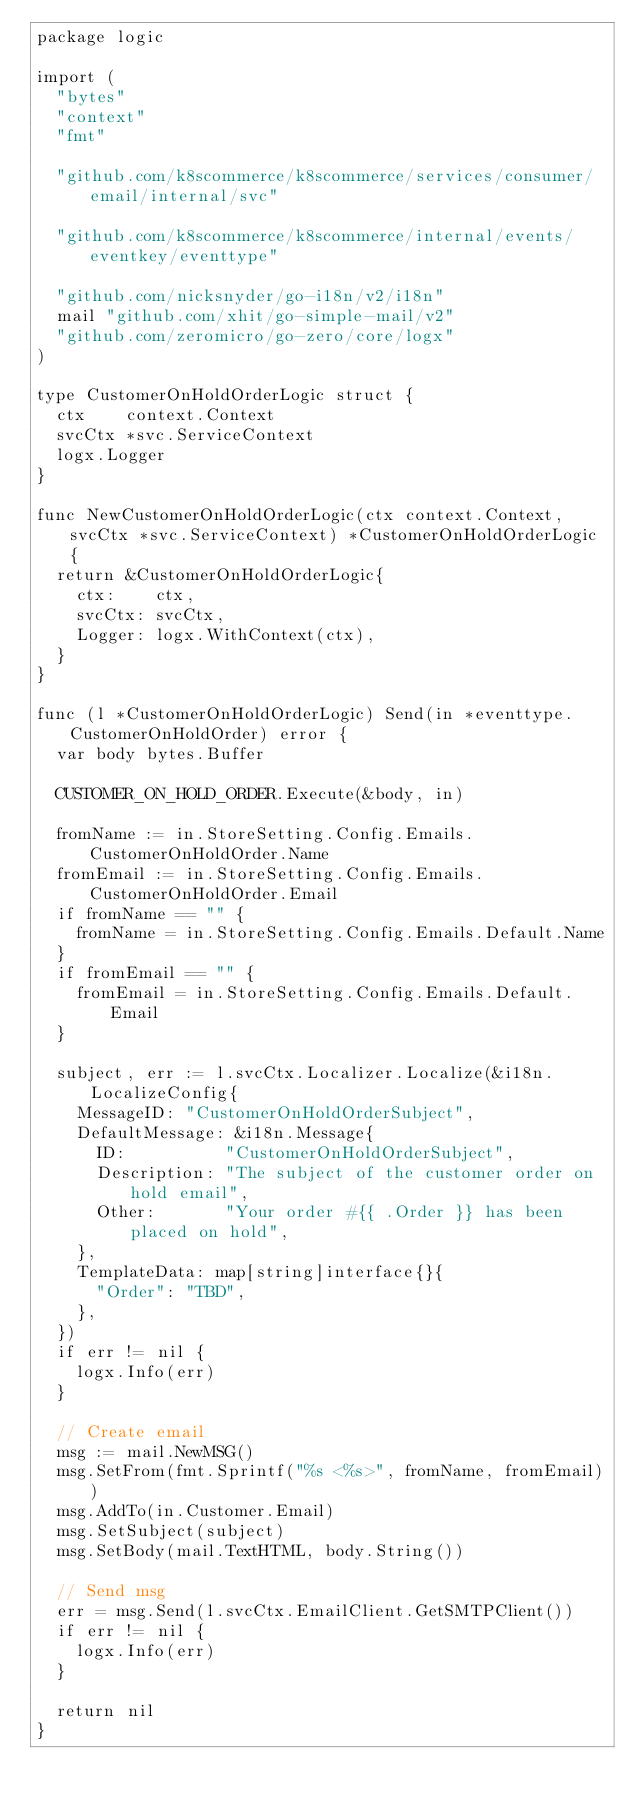<code> <loc_0><loc_0><loc_500><loc_500><_Go_>package logic

import (
	"bytes"
	"context"
	"fmt"

	"github.com/k8scommerce/k8scommerce/services/consumer/email/internal/svc"

	"github.com/k8scommerce/k8scommerce/internal/events/eventkey/eventtype"

	"github.com/nicksnyder/go-i18n/v2/i18n"
	mail "github.com/xhit/go-simple-mail/v2"
	"github.com/zeromicro/go-zero/core/logx"
)

type CustomerOnHoldOrderLogic struct {
	ctx    context.Context
	svcCtx *svc.ServiceContext
	logx.Logger
}

func NewCustomerOnHoldOrderLogic(ctx context.Context, svcCtx *svc.ServiceContext) *CustomerOnHoldOrderLogic {
	return &CustomerOnHoldOrderLogic{
		ctx:    ctx,
		svcCtx: svcCtx,
		Logger: logx.WithContext(ctx),
	}
}

func (l *CustomerOnHoldOrderLogic) Send(in *eventtype.CustomerOnHoldOrder) error {
	var body bytes.Buffer

	CUSTOMER_ON_HOLD_ORDER.Execute(&body, in)

	fromName := in.StoreSetting.Config.Emails.CustomerOnHoldOrder.Name
	fromEmail := in.StoreSetting.Config.Emails.CustomerOnHoldOrder.Email
	if fromName == "" {
		fromName = in.StoreSetting.Config.Emails.Default.Name
	}
	if fromEmail == "" {
		fromEmail = in.StoreSetting.Config.Emails.Default.Email
	}

	subject, err := l.svcCtx.Localizer.Localize(&i18n.LocalizeConfig{
		MessageID: "CustomerOnHoldOrderSubject",
		DefaultMessage: &i18n.Message{
			ID:          "CustomerOnHoldOrderSubject",
			Description: "The subject of the customer order on hold email",
			Other:       "Your order #{{ .Order }} has been placed on hold",
		},
		TemplateData: map[string]interface{}{
			"Order": "TBD",
		},
	})
	if err != nil {
		logx.Info(err)
	}

	// Create email
	msg := mail.NewMSG()
	msg.SetFrom(fmt.Sprintf("%s <%s>", fromName, fromEmail))
	msg.AddTo(in.Customer.Email)
	msg.SetSubject(subject)
	msg.SetBody(mail.TextHTML, body.String())

	// Send msg
	err = msg.Send(l.svcCtx.EmailClient.GetSMTPClient())
	if err != nil {
		logx.Info(err)
	}

	return nil
}
</code> 